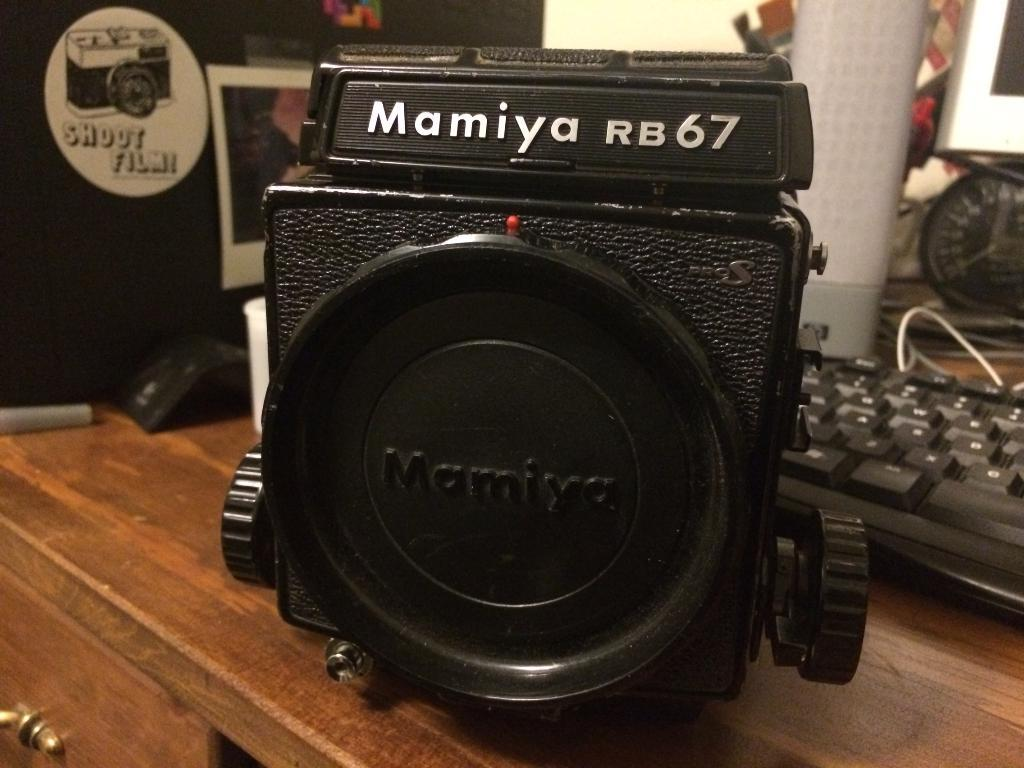What piece of furniture is present in the image? There is a table in the image. What electronic device is on the table? There is a keyboard on the table. What other electronic device is on the table? There is a camera on the table. What type of object is used for organization or display on the table? There is a clock on the table. What type of object is used for decoration on the table? There is a poster on the table. What else can be seen on the table besides the mentioned items? There are other unspecified objects on the table. What songs are being played on the keyboard in the image? There is no indication in the image that the keyboard is being played, so it cannot be determined which songs might be played. 